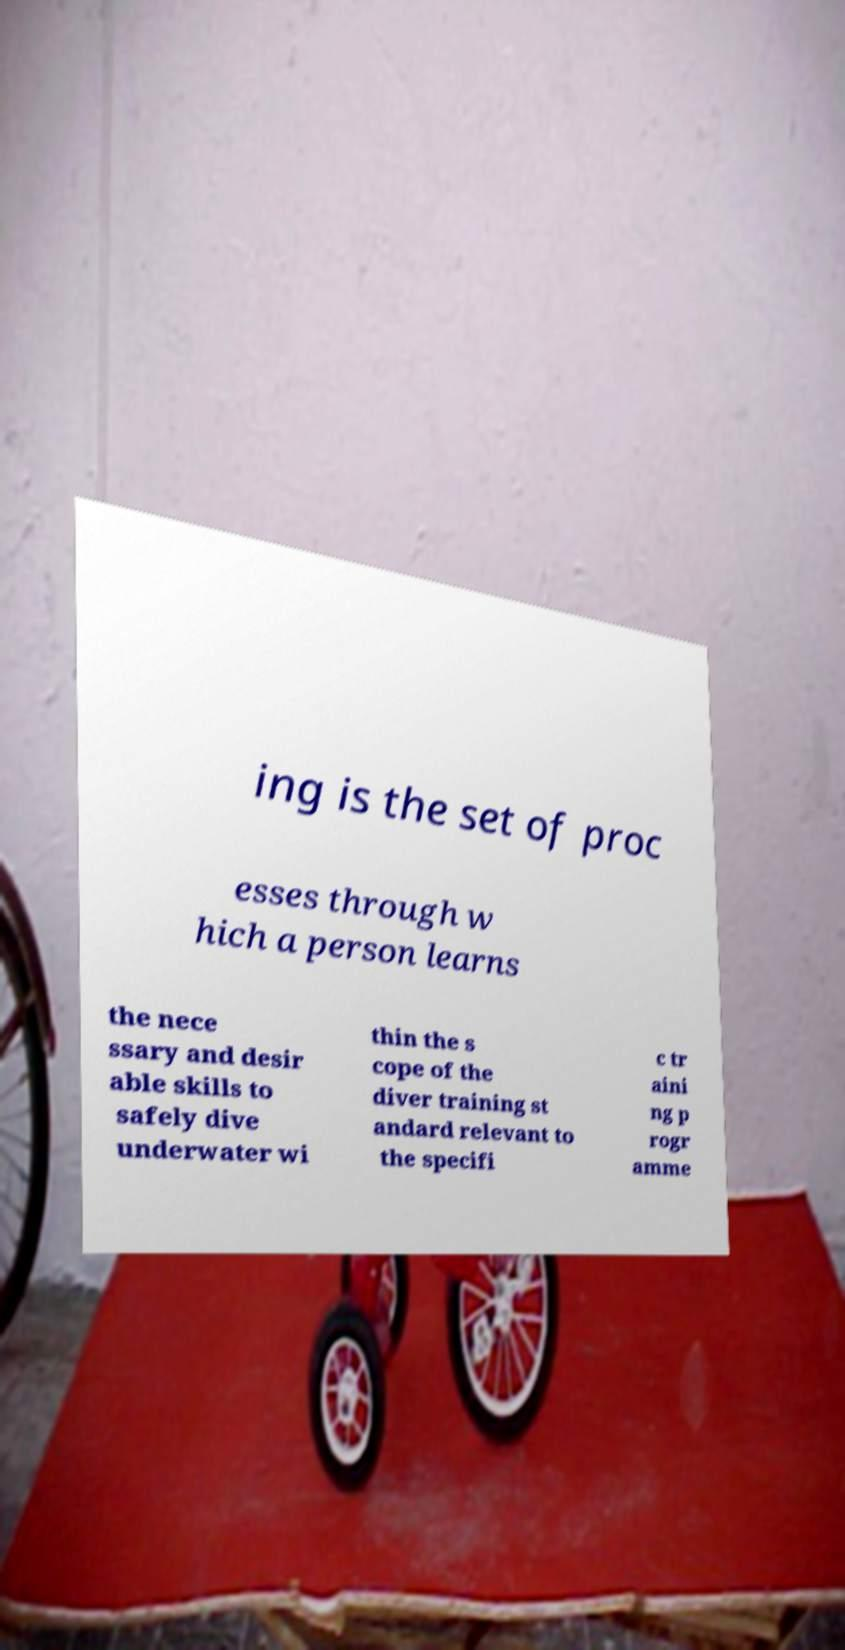Can you accurately transcribe the text from the provided image for me? ing is the set of proc esses through w hich a person learns the nece ssary and desir able skills to safely dive underwater wi thin the s cope of the diver training st andard relevant to the specifi c tr aini ng p rogr amme 